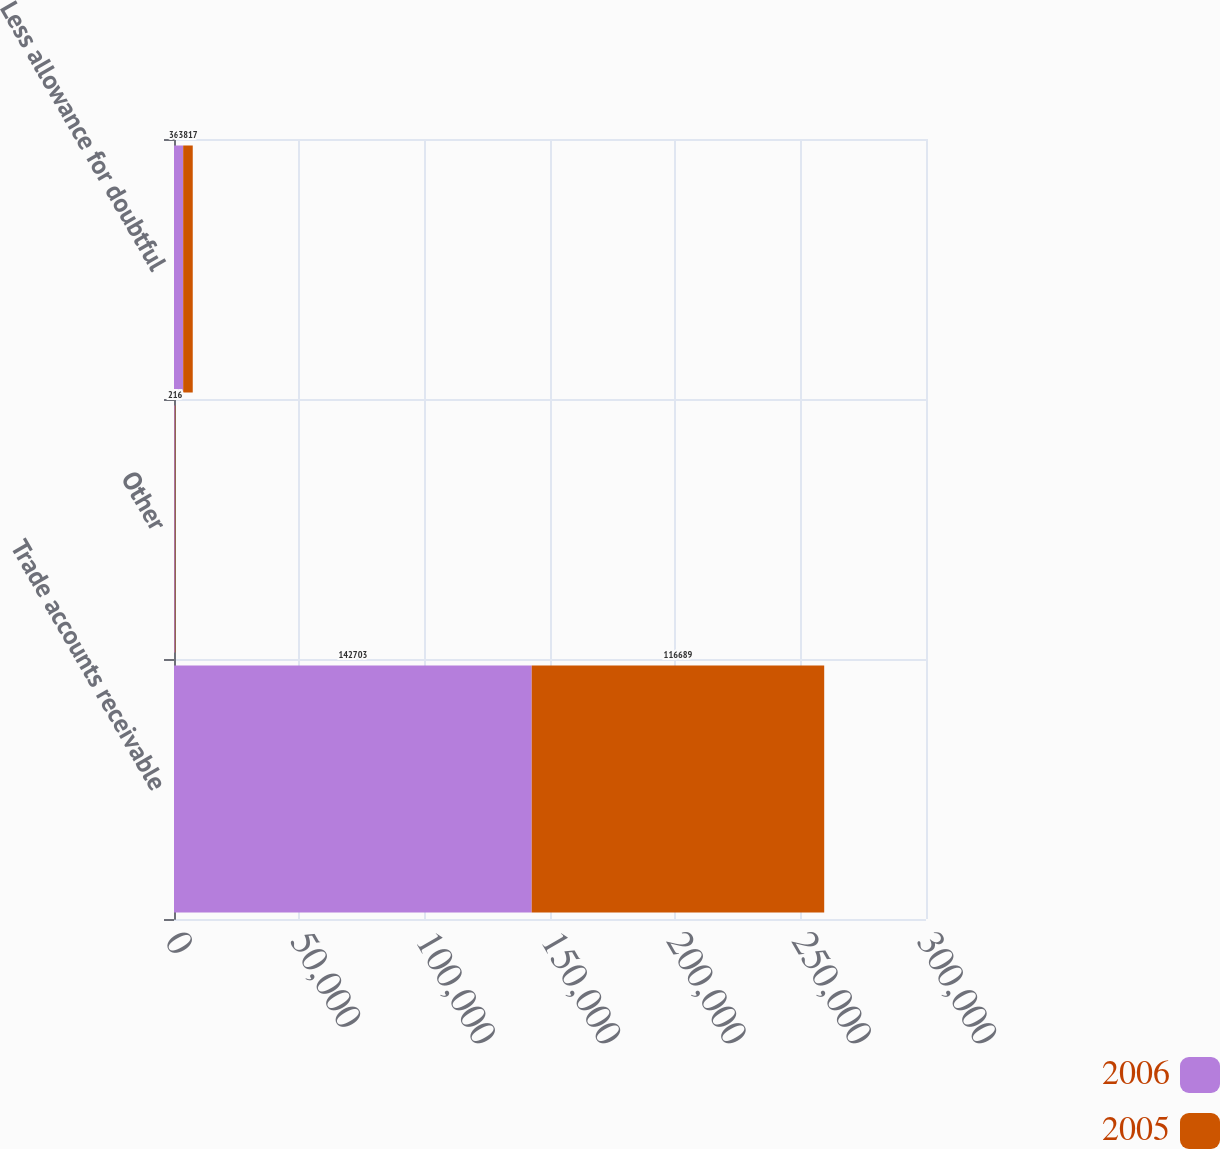Convert chart to OTSL. <chart><loc_0><loc_0><loc_500><loc_500><stacked_bar_chart><ecel><fcel>Trade accounts receivable<fcel>Other<fcel>Less allowance for doubtful<nl><fcel>2006<fcel>142703<fcel>320<fcel>3662<nl><fcel>2005<fcel>116689<fcel>216<fcel>3817<nl></chart> 